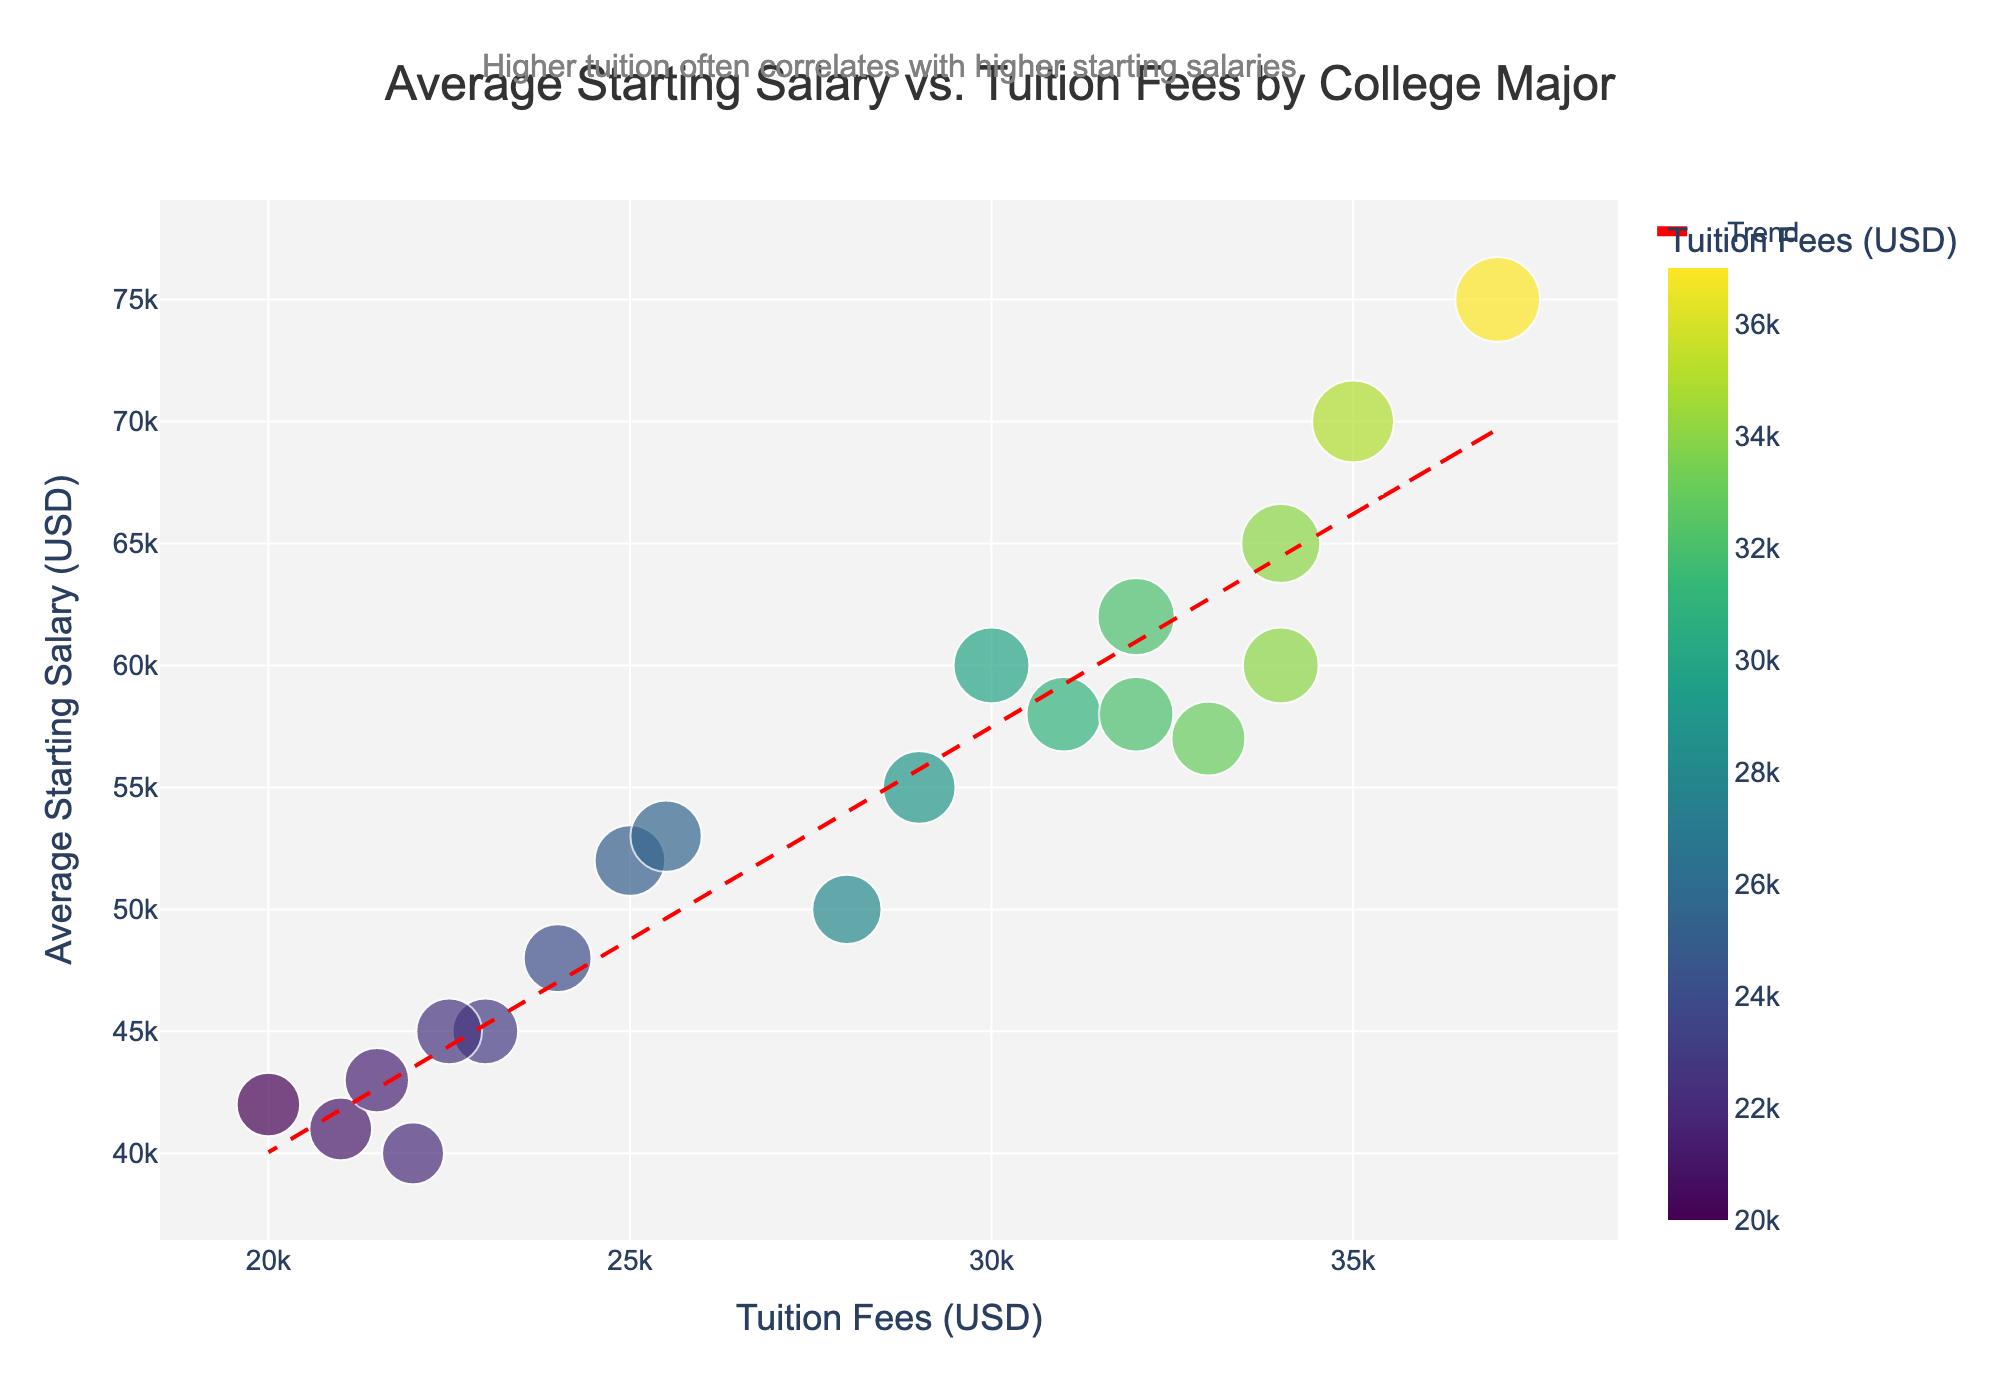What is the title of the scatter plot? The title of the scatter plot is written in a larger font above the plot area. It says "Average Starting Salary vs. Tuition Fees by College Major".
Answer: Average Starting Salary vs. Tuition Fees by College Major What do the colors in the scatter plot represent? The colors correspond to different tuition fee ranges, with a color scale that transitions as the tuition fees increase.
Answer: Tuition Fees What are the x-axis and y-axis labels? The labels are placed alongside the respective axes. The x-axis is labeled "Tuition Fees (USD)" and the y-axis is labeled "Average Starting Salary (USD)".
Answer: Tuition Fees (USD), Average Starting Salary (USD) How many data points are shown in the scatter plot? Each point represents a college major and the scatter plot has points corresponding to each of the majors listed in the data. Counting these will give us 18 points.
Answer: 18 What is the average starting salary for Engineering majors? Extract the starting salaries of majors with "Engineering" in their names: Computer Science ($70,000), Electrical Engineering ($65,000), Mechanical Engineering ($62,000), Information Technology ($60,000), Civil Engineering ($58,000), Chemical Engineering ($75,000). Add these and divide by the number of majors: (70,000 + 65,000 + 62,000 + 60,000 + 58,000 + 75,000) / 6.
Answer: $65,000 What is the difference in average starting salary between Computer Science and Psychology? Find the average starting salaries for both majors from the plot. Computer Science is $70,000 and Psychology is $45,000. Subtract the latter from the former: $70,000 - $45,000.
Answer: $25,000 Which college major has the highest starting salary and what is it? Look for the highest point on the y-axis, which represents the highest salary. The corresponding college major, visible from the hover text or nearby annotations, is Chemical Engineering.
Answer: Chemical Engineering, $75,000 Which major has a higher starting salary, Nursing or Education? Locate the points representing Nursing and Education and compare their positions on the y-axis. Nursing has a starting salary of $55,000, and Education has $40,000.
Answer: Nursing What trend is indicated by the dashed red line? The dashed red line represents a trend line fitted to the data points. It shows the general relationship between tuition fees and starting salary, suggesting that higher tuition fees often correlate with higher starting salaries.
Answer: Higher tuition correlates with higher starting salaries Is there an outlier in terms of starting salary for majors with similar tuition fees? Observe the general trend and find any points that deviate significantly. Computer Science and Chemical Engineering have higher salaries than expected compared to other majors with similar tuition fees.
Answer: Computer Science, Chemical Engineering 